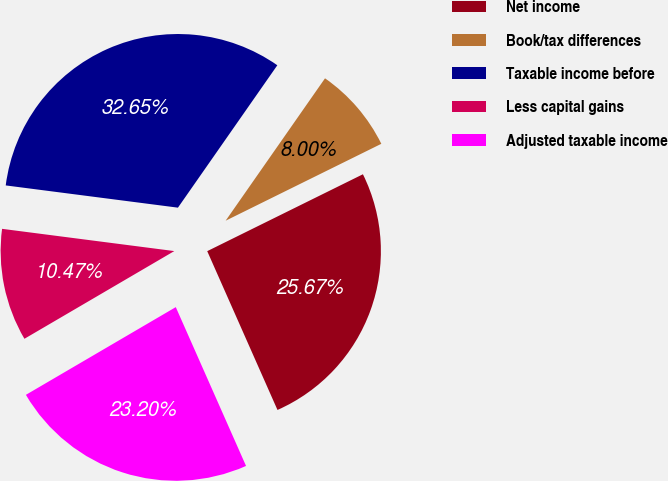Convert chart. <chart><loc_0><loc_0><loc_500><loc_500><pie_chart><fcel>Net income<fcel>Book/tax differences<fcel>Taxable income before<fcel>Less capital gains<fcel>Adjusted taxable income<nl><fcel>25.67%<fcel>8.0%<fcel>32.65%<fcel>10.47%<fcel>23.2%<nl></chart> 